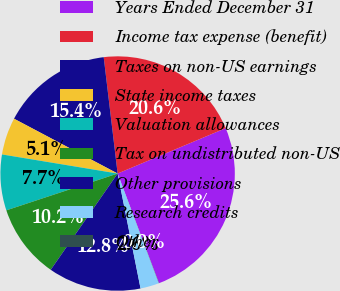Convert chart. <chart><loc_0><loc_0><loc_500><loc_500><pie_chart><fcel>Years Ended December 31<fcel>Income tax expense (benefit)<fcel>Taxes on non-US earnings<fcel>State income taxes<fcel>Valuation allowances<fcel>Tax on undistributed non-US<fcel>Other provisions<fcel>Research credits<fcel>Other<nl><fcel>25.58%<fcel>20.57%<fcel>15.36%<fcel>5.14%<fcel>7.69%<fcel>10.25%<fcel>12.8%<fcel>2.58%<fcel>0.03%<nl></chart> 